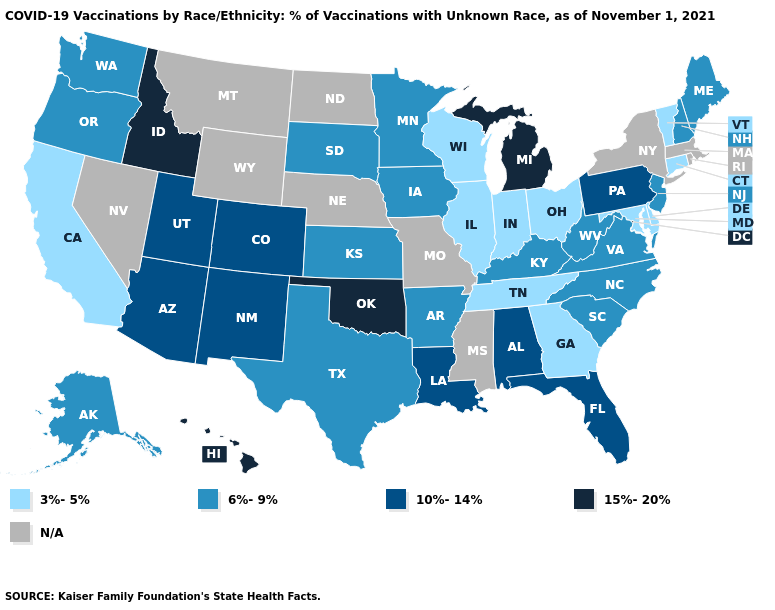What is the value of West Virginia?
Be succinct. 6%-9%. What is the highest value in the MidWest ?
Give a very brief answer. 15%-20%. Does Oklahoma have the highest value in the South?
Short answer required. Yes. Among the states that border Maryland , which have the highest value?
Answer briefly. Pennsylvania. What is the value of Alaska?
Give a very brief answer. 6%-9%. What is the highest value in the USA?
Be succinct. 15%-20%. What is the value of Kansas?
Short answer required. 6%-9%. Name the states that have a value in the range 15%-20%?
Short answer required. Hawaii, Idaho, Michigan, Oklahoma. Does California have the lowest value in the West?
Answer briefly. Yes. Does the map have missing data?
Answer briefly. Yes. Which states have the lowest value in the USA?
Be succinct. California, Connecticut, Delaware, Georgia, Illinois, Indiana, Maryland, Ohio, Tennessee, Vermont, Wisconsin. Name the states that have a value in the range N/A?
Concise answer only. Massachusetts, Mississippi, Missouri, Montana, Nebraska, Nevada, New York, North Dakota, Rhode Island, Wyoming. What is the value of New Mexico?
Concise answer only. 10%-14%. Does Florida have the lowest value in the USA?
Give a very brief answer. No. 